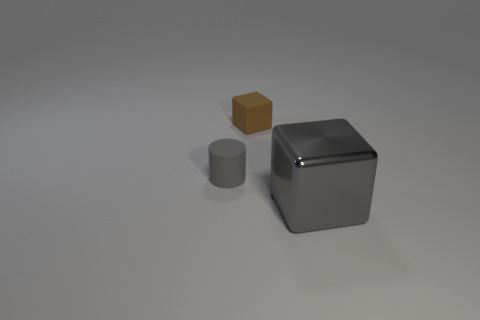Is there any other thing that has the same material as the tiny brown object?
Your response must be concise. Yes. There is a block that is to the left of the cube right of the block to the left of the large gray thing; what is its size?
Your response must be concise. Small. How big is the matte object that is behind the small rubber cylinder?
Offer a very short reply. Small. There is a gray thing that is on the right side of the tiny gray matte object; what material is it?
Offer a very short reply. Metal. What number of gray objects are either matte objects or metal blocks?
Your answer should be compact. 2. Is the material of the large gray cube the same as the gray thing to the left of the brown object?
Provide a short and direct response. No. Are there the same number of rubber objects to the right of the tiny rubber cube and brown matte objects that are to the right of the tiny gray cylinder?
Provide a succinct answer. No. There is a brown thing; is it the same size as the object that is right of the brown rubber thing?
Your answer should be very brief. No. Is the number of tiny gray rubber objects that are behind the brown matte thing greater than the number of tiny brown matte things?
Provide a succinct answer. No. What number of metallic blocks are the same size as the matte cylinder?
Keep it short and to the point. 0. 